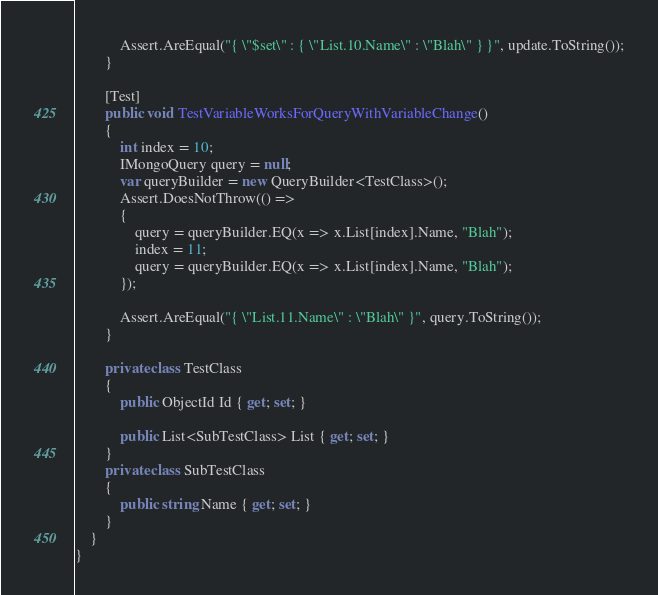<code> <loc_0><loc_0><loc_500><loc_500><_C#_>
            Assert.AreEqual("{ \"$set\" : { \"List.10.Name\" : \"Blah\" } }", update.ToString());
        }

        [Test]
        public void TestVariableWorksForQueryWithVariableChange()
        {
            int index = 10;
            IMongoQuery query = null;
            var queryBuilder = new QueryBuilder<TestClass>();
            Assert.DoesNotThrow(() =>
            {
                query = queryBuilder.EQ(x => x.List[index].Name, "Blah");
                index = 11;
                query = queryBuilder.EQ(x => x.List[index].Name, "Blah");
            });

            Assert.AreEqual("{ \"List.11.Name\" : \"Blah\" }", query.ToString());
        }

        private class TestClass
        {
            public ObjectId Id { get; set; }

            public List<SubTestClass> List { get; set; }
        }
        private class SubTestClass
        {
            public string Name { get; set; }
        }
    }
}</code> 